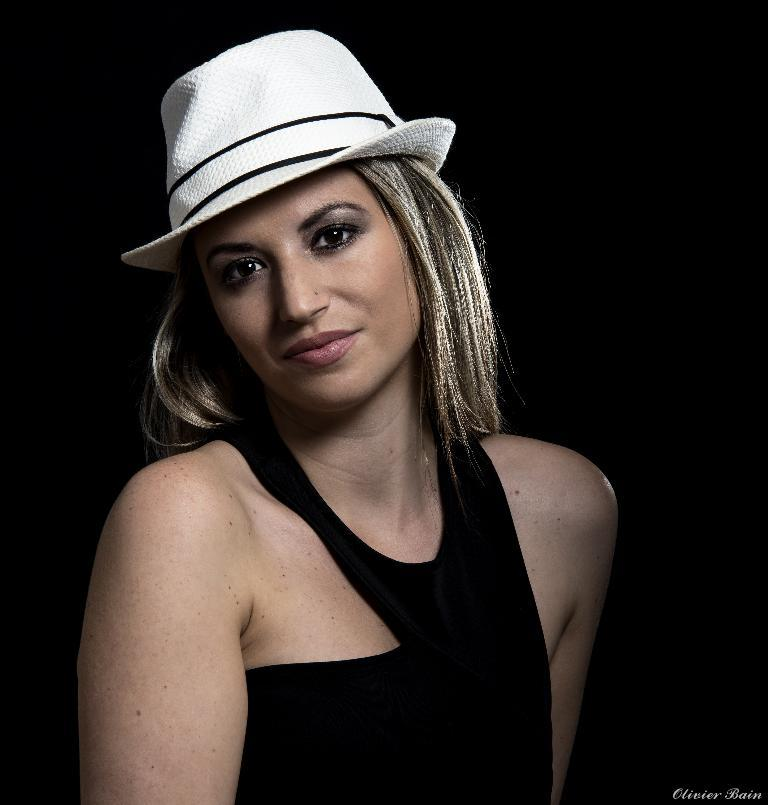Who is the main subject in the picture? There is a girl in the picture. What is the girl wearing on her upper body? The girl is wearing a black top. What is the girl wearing on her head? The girl is wearing a white cap. What is the girl's facial expression in the picture? The girl is smiling. What is the girl doing in the picture? The girl is giving a pose for the camera. What is the color of the background in the image? There is a black background in the image. What type of jewel can be seen in the girl's hand in the image? There is no jewel visible in the girl's hand in the image. What kind of toys is the girl playing with in the image? There are no toys present in the image; the girl is posing for the camera. 